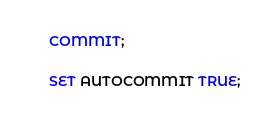<code> <loc_0><loc_0><loc_500><loc_500><_SQL_>

COMMIT;

SET AUTOCOMMIT TRUE;
</code> 